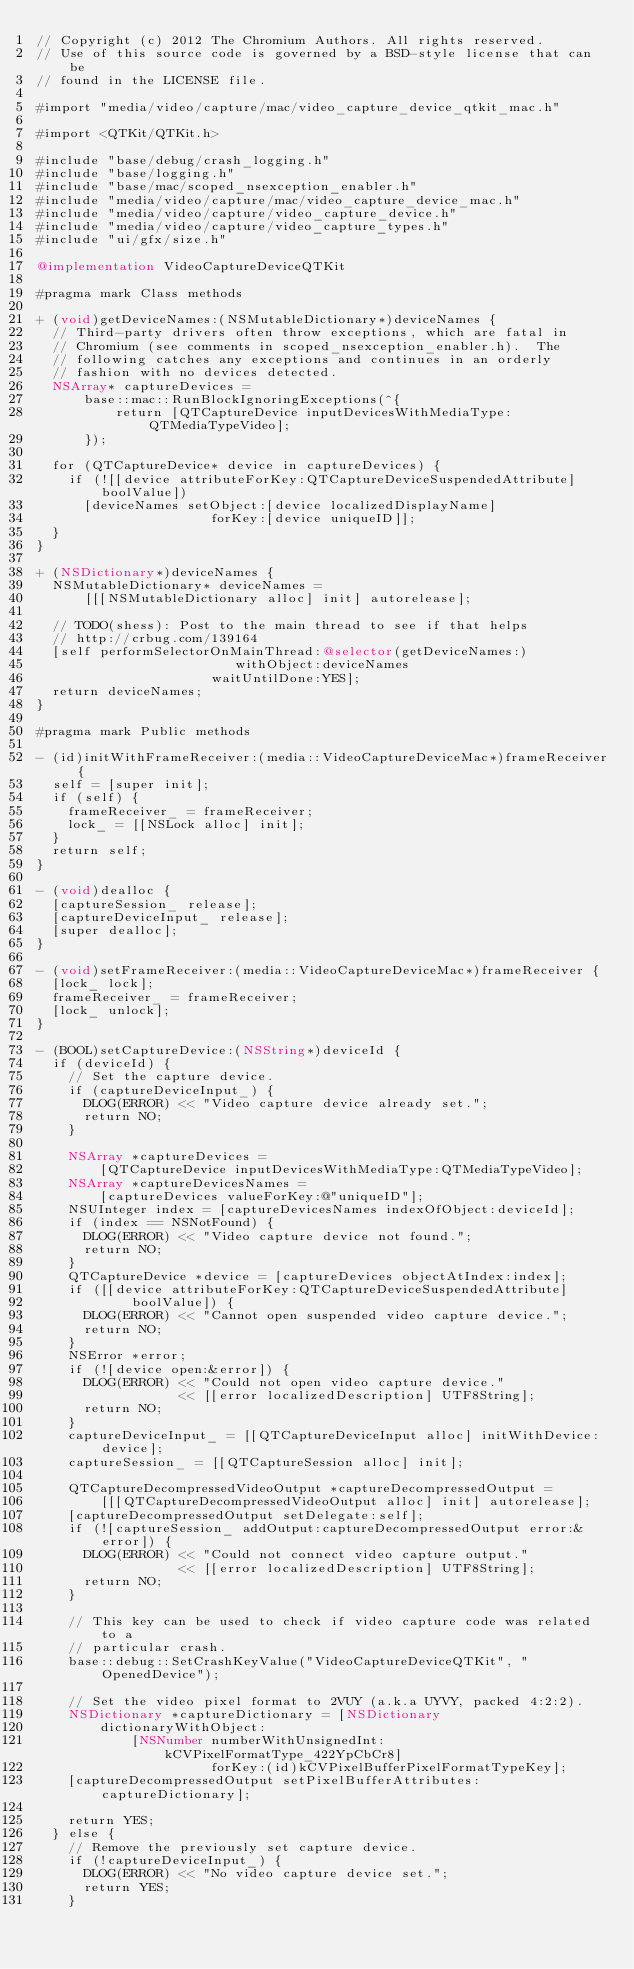Convert code to text. <code><loc_0><loc_0><loc_500><loc_500><_ObjectiveC_>// Copyright (c) 2012 The Chromium Authors. All rights reserved.
// Use of this source code is governed by a BSD-style license that can be
// found in the LICENSE file.

#import "media/video/capture/mac/video_capture_device_qtkit_mac.h"

#import <QTKit/QTKit.h>

#include "base/debug/crash_logging.h"
#include "base/logging.h"
#include "base/mac/scoped_nsexception_enabler.h"
#include "media/video/capture/mac/video_capture_device_mac.h"
#include "media/video/capture/video_capture_device.h"
#include "media/video/capture/video_capture_types.h"
#include "ui/gfx/size.h"

@implementation VideoCaptureDeviceQTKit

#pragma mark Class methods

+ (void)getDeviceNames:(NSMutableDictionary*)deviceNames {
  // Third-party drivers often throw exceptions, which are fatal in
  // Chromium (see comments in scoped_nsexception_enabler.h).  The
  // following catches any exceptions and continues in an orderly
  // fashion with no devices detected.
  NSArray* captureDevices =
      base::mac::RunBlockIgnoringExceptions(^{
          return [QTCaptureDevice inputDevicesWithMediaType:QTMediaTypeVideo];
      });

  for (QTCaptureDevice* device in captureDevices) {
    if (![[device attributeForKey:QTCaptureDeviceSuspendedAttribute] boolValue])
      [deviceNames setObject:[device localizedDisplayName]
                      forKey:[device uniqueID]];
  }
}

+ (NSDictionary*)deviceNames {
  NSMutableDictionary* deviceNames =
      [[[NSMutableDictionary alloc] init] autorelease];

  // TODO(shess): Post to the main thread to see if that helps
  // http://crbug.com/139164
  [self performSelectorOnMainThread:@selector(getDeviceNames:)
                         withObject:deviceNames
                      waitUntilDone:YES];
  return deviceNames;
}

#pragma mark Public methods

- (id)initWithFrameReceiver:(media::VideoCaptureDeviceMac*)frameReceiver {
  self = [super init];
  if (self) {
    frameReceiver_ = frameReceiver;
    lock_ = [[NSLock alloc] init];
  }
  return self;
}

- (void)dealloc {
  [captureSession_ release];
  [captureDeviceInput_ release];
  [super dealloc];
}

- (void)setFrameReceiver:(media::VideoCaptureDeviceMac*)frameReceiver {
  [lock_ lock];
  frameReceiver_ = frameReceiver;
  [lock_ unlock];
}

- (BOOL)setCaptureDevice:(NSString*)deviceId {
  if (deviceId) {
    // Set the capture device.
    if (captureDeviceInput_) {
      DLOG(ERROR) << "Video capture device already set.";
      return NO;
    }

    NSArray *captureDevices =
        [QTCaptureDevice inputDevicesWithMediaType:QTMediaTypeVideo];
    NSArray *captureDevicesNames =
        [captureDevices valueForKey:@"uniqueID"];
    NSUInteger index = [captureDevicesNames indexOfObject:deviceId];
    if (index == NSNotFound) {
      DLOG(ERROR) << "Video capture device not found.";
      return NO;
    }
    QTCaptureDevice *device = [captureDevices objectAtIndex:index];
    if ([[device attributeForKey:QTCaptureDeviceSuspendedAttribute]
            boolValue]) {
      DLOG(ERROR) << "Cannot open suspended video capture device.";
      return NO;
    }
    NSError *error;
    if (![device open:&error]) {
      DLOG(ERROR) << "Could not open video capture device."
                  << [[error localizedDescription] UTF8String];
      return NO;
    }
    captureDeviceInput_ = [[QTCaptureDeviceInput alloc] initWithDevice:device];
    captureSession_ = [[QTCaptureSession alloc] init];

    QTCaptureDecompressedVideoOutput *captureDecompressedOutput =
        [[[QTCaptureDecompressedVideoOutput alloc] init] autorelease];
    [captureDecompressedOutput setDelegate:self];
    if (![captureSession_ addOutput:captureDecompressedOutput error:&error]) {
      DLOG(ERROR) << "Could not connect video capture output."
                  << [[error localizedDescription] UTF8String];
      return NO;
    }

    // This key can be used to check if video capture code was related to a
    // particular crash.
    base::debug::SetCrashKeyValue("VideoCaptureDeviceQTKit", "OpenedDevice");

    // Set the video pixel format to 2VUY (a.k.a UYVY, packed 4:2:2).
    NSDictionary *captureDictionary = [NSDictionary
        dictionaryWithObject:
            [NSNumber numberWithUnsignedInt:kCVPixelFormatType_422YpCbCr8]
                      forKey:(id)kCVPixelBufferPixelFormatTypeKey];
    [captureDecompressedOutput setPixelBufferAttributes:captureDictionary];

    return YES;
  } else {
    // Remove the previously set capture device.
    if (!captureDeviceInput_) {
      DLOG(ERROR) << "No video capture device set.";
      return YES;
    }</code> 